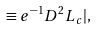<formula> <loc_0><loc_0><loc_500><loc_500>\equiv e ^ { - 1 } D ^ { 2 } L _ { c } | ,</formula> 